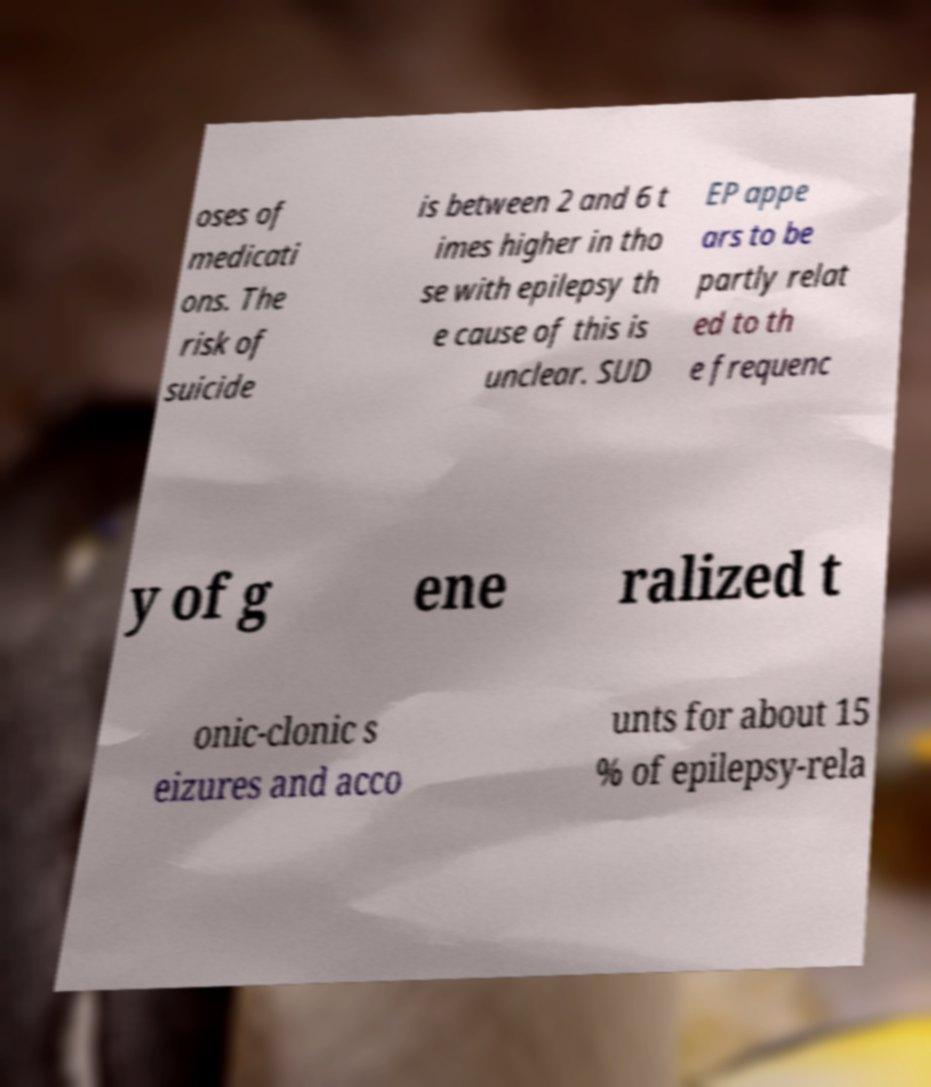Can you read and provide the text displayed in the image?This photo seems to have some interesting text. Can you extract and type it out for me? oses of medicati ons. The risk of suicide is between 2 and 6 t imes higher in tho se with epilepsy th e cause of this is unclear. SUD EP appe ars to be partly relat ed to th e frequenc y of g ene ralized t onic-clonic s eizures and acco unts for about 15 % of epilepsy-rela 